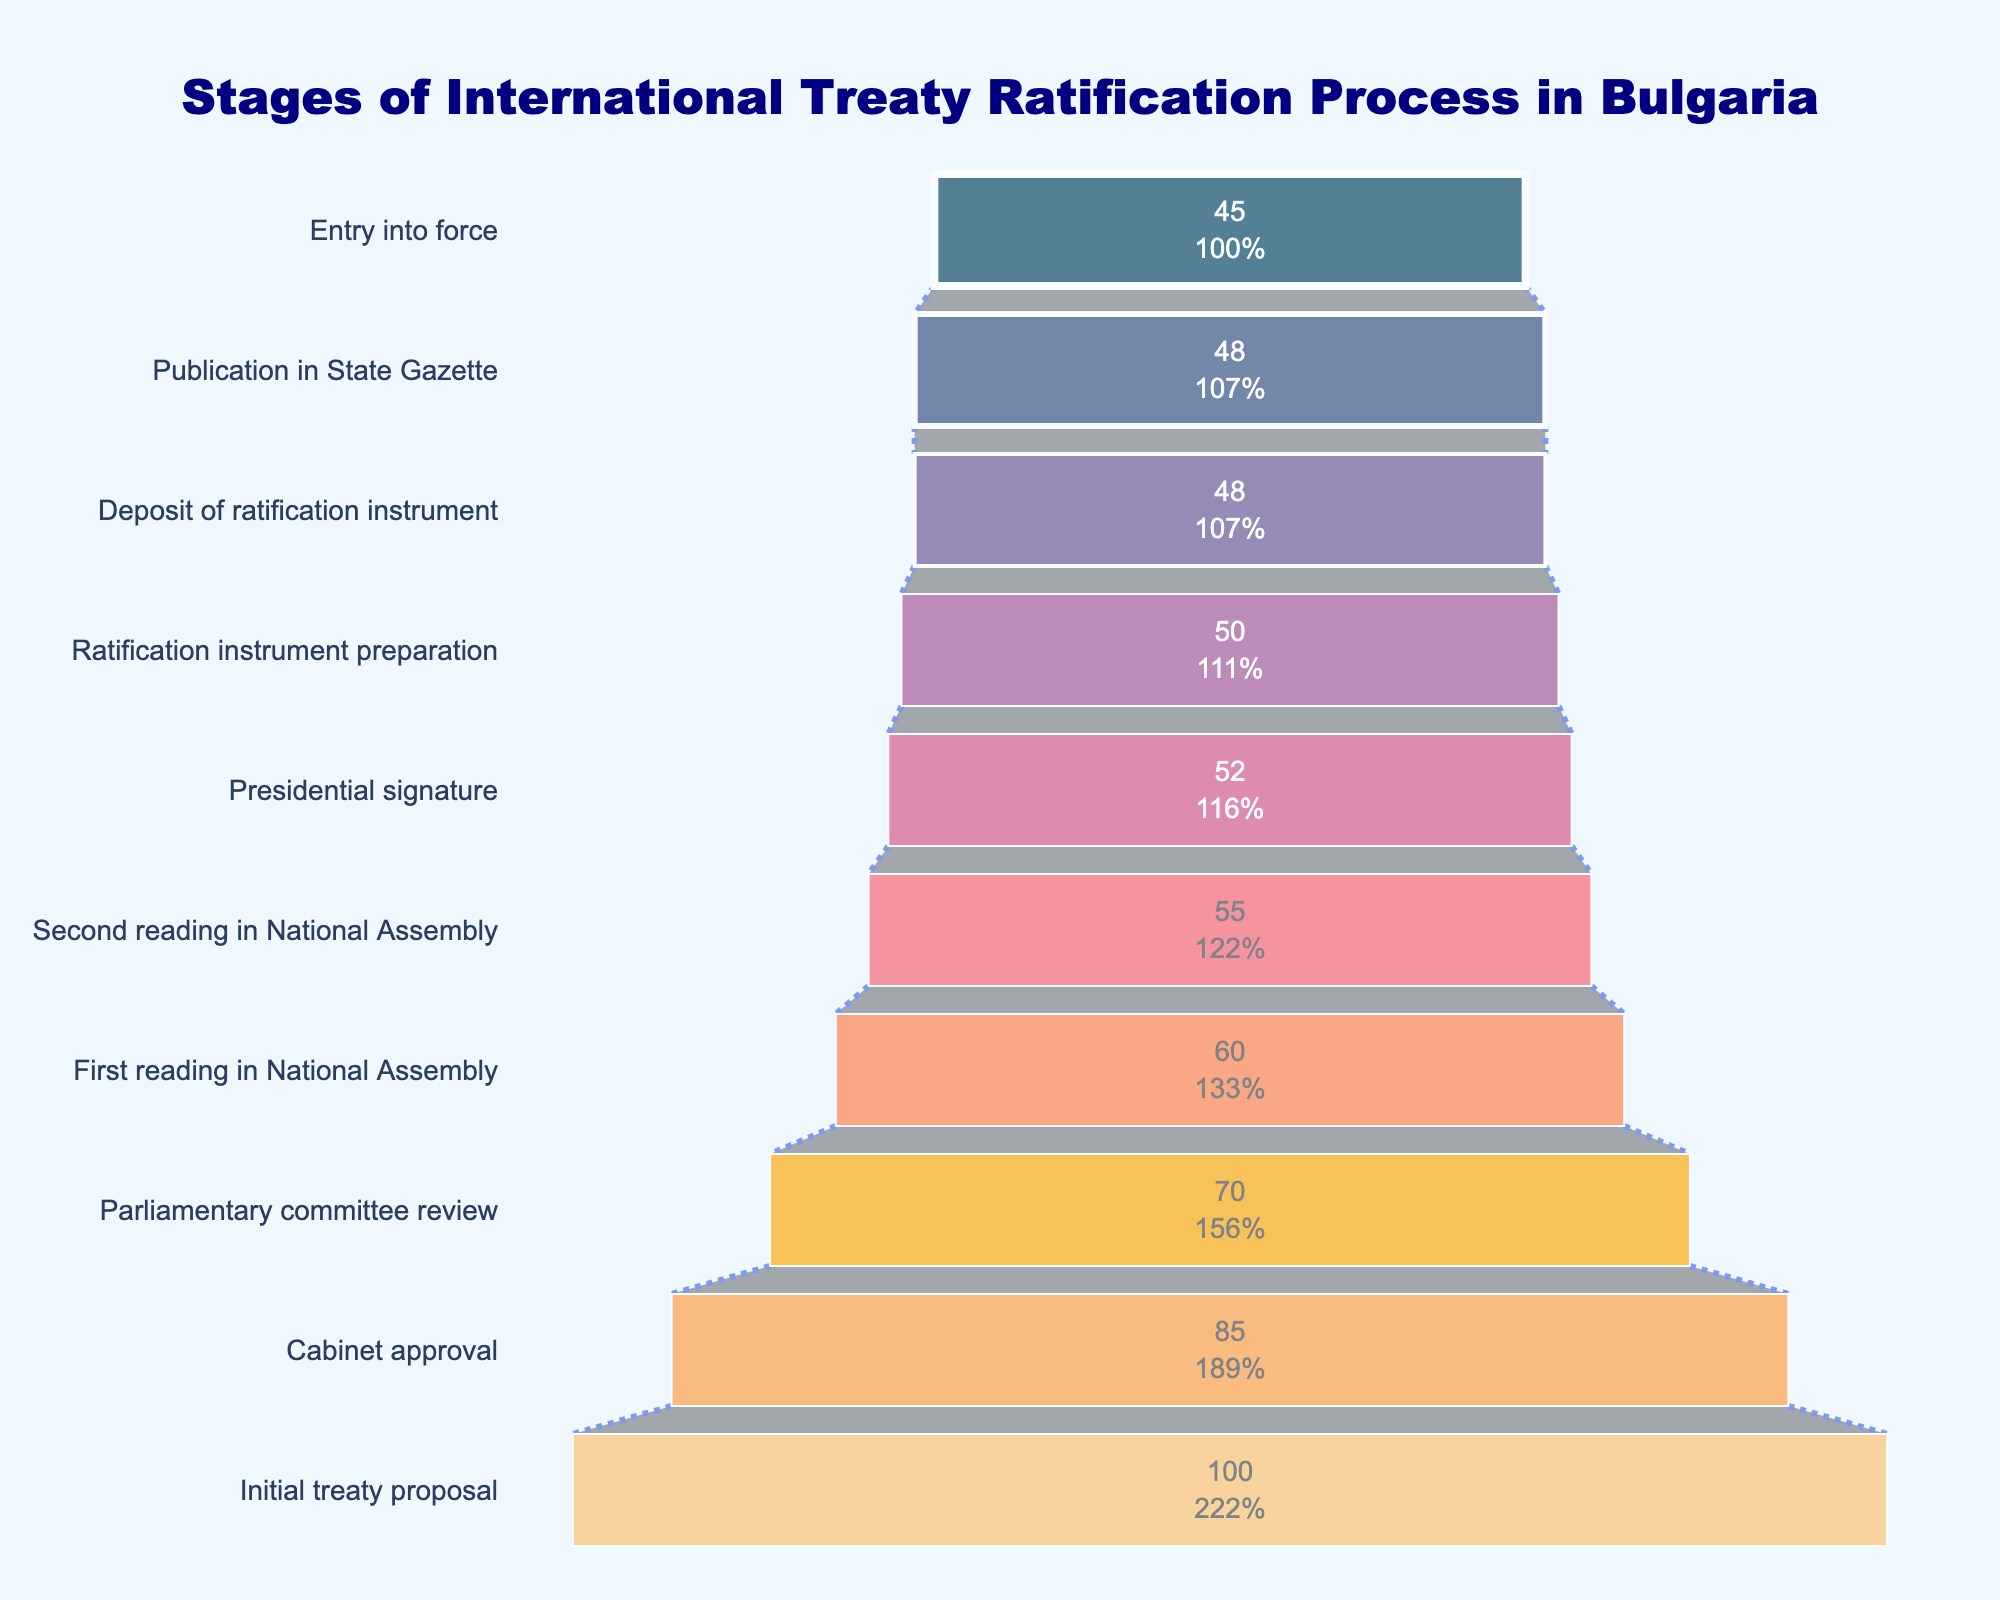What's the title of the funnel chart? The title is located at the top center of the chart. It provides an overview of the data being presented. By looking at the chart's top, the title reads "Stages of International Treaty Ratification Process in Bulgaria".
Answer: Stages of International Treaty Ratification Process in Bulgaria How many stages are displayed in the funnel chart? By counting the funnel segments from the bottom to the top of the chart, you can see each represents a different stage. There are 10 stages displayed.
Answer: 10 At which stage does the largest drop in count occur? To determine the largest drop, observe the differences in counts between consecutive stages. The largest drop is from "Cabinet approval" with 85 to "Parliamentary committee review" with 70, equating to a difference of 15.
Answer: From Cabinet approval to Parliamentary committee review What's the percentage of treaties that make it from "Initial treaty proposal" to "Entry into force"? Initially, there are 100 treaties, and 45 reach the "Entry into force" stage. The percentage is calculated as (45/100) * 100%.
Answer: 45% What is the count at the "Second reading in National Assembly" stage? You can read the count directly from the funnel chart segment labeled "Second reading in National Assembly". It shows a count of 55.
Answer: 55 Which stage has the smallest count? The final segment at the very bottom of the chart, labeled "Entry into force", shows the smallest count, which is 45.
Answer: Entry into force What is the difference in count between "First reading in National Assembly" and "Presidential signature"? Subtract the count at "Presidential signature" (52) from that at "First reading in National Assembly" (60). The difference is 60 - 52 = 8.
Answer: 8 What proportion of the treaties reach the "Publication in State Gazette" stage from those that started at "Initial treaty proposal"? The number of treaties at "Initial treaty proposal" is 100, and at "Publication in State Gazette" is 48. Calculate the proportion as 48/100 = 0.48 or 48%.
Answer: 48% How many stages have more than 50 treaties? Count the stages with a count greater than 50 by looking through the funnel chart segments. There are 6 stages: "Initial treaty proposal", "Cabinet approval", "Parliamentary committee review", "First reading in National Assembly", "Second reading in National Assembly", and "Presidential signature".
Answer: 6 How many stages are required to prepare the instrument of ratification from the initial proposal? Identify the stages from "Initial treaty proposal" to "Ratification instrument preparation" by counting the segments from the top until reaching "Ratification instrument preparation." The stages are: "Initial treaty proposal", "Cabinet approval", "Parliamentary committee review", "First reading in National Assembly", "Second reading in National Assembly", "Presidential signature", and "Ratification instrument preparation", totaling 7 stages.
Answer: 7 